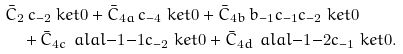<formula> <loc_0><loc_0><loc_500><loc_500>& \bar { C } _ { 2 } \, c _ { - 2 } \ k e t { 0 } + \bar { C } _ { 4 a } \, c _ { - 4 } \ k e t { 0 } + \bar { C } _ { 4 b } \, b _ { - 1 } c _ { - 1 } c _ { - 2 } \ k e t { 0 } \\ & \quad + \bar { C } _ { 4 c } \, \ a l a l { - 1 } { - 1 } c _ { - 2 } \ k e t { 0 } + \bar { C } _ { 4 d } \, \ a l a l { - 1 } { - 2 } c _ { - 1 } \ k e t { 0 } .</formula> 